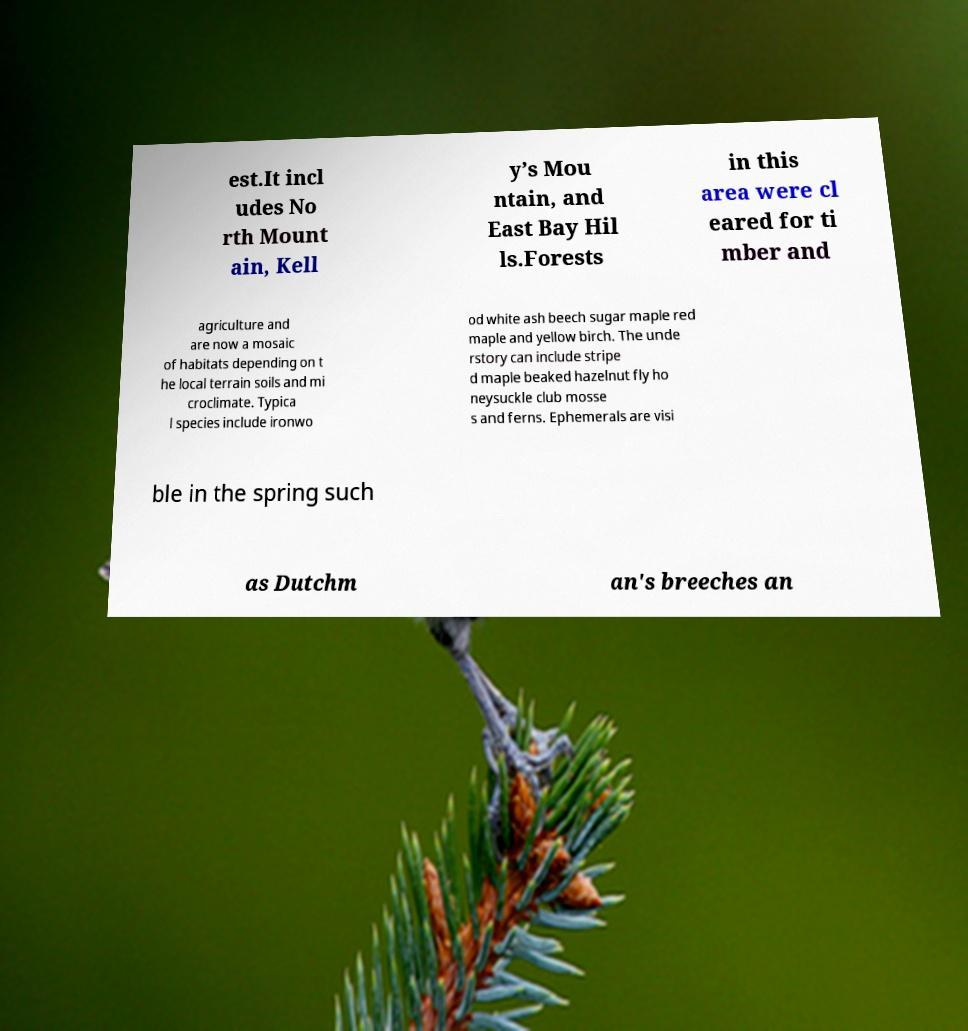Could you extract and type out the text from this image? est.It incl udes No rth Mount ain, Kell y’s Mou ntain, and East Bay Hil ls.Forests in this area were cl eared for ti mber and agriculture and are now a mosaic of habitats depending on t he local terrain soils and mi croclimate. Typica l species include ironwo od white ash beech sugar maple red maple and yellow birch. The unde rstory can include stripe d maple beaked hazelnut fly ho neysuckle club mosse s and ferns. Ephemerals are visi ble in the spring such as Dutchm an's breeches an 